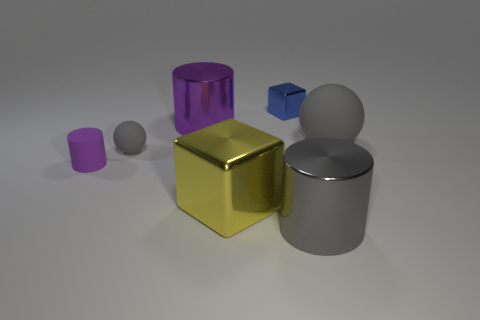How many other things are the same color as the large rubber sphere?
Your answer should be very brief. 2. How many objects are either objects that are left of the big shiny cube or metal cubes that are left of the big gray matte sphere?
Make the answer very short. 5. Is the color of the big rubber object the same as the tiny matte ball?
Your answer should be compact. Yes. What material is the other ball that is the same color as the big ball?
Ensure brevity in your answer.  Rubber. Is the number of spheres that are left of the blue metal cube less than the number of rubber things in front of the large purple shiny thing?
Ensure brevity in your answer.  Yes. Is the material of the big yellow object the same as the blue thing?
Your answer should be compact. Yes. There is a gray object that is to the right of the yellow shiny object and behind the yellow shiny object; what is its size?
Offer a terse response. Large. The blue object that is the same size as the matte cylinder is what shape?
Give a very brief answer. Cube. What is the material of the purple object that is in front of the gray sphere left of the metallic cylinder behind the gray metal thing?
Provide a short and direct response. Rubber. Do the metal thing to the right of the blue metallic cube and the purple object behind the big matte sphere have the same shape?
Your answer should be compact. Yes. 